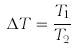Convert formula to latex. <formula><loc_0><loc_0><loc_500><loc_500>\Delta T = \frac { T _ { 1 } } { T _ { 2 } }</formula> 